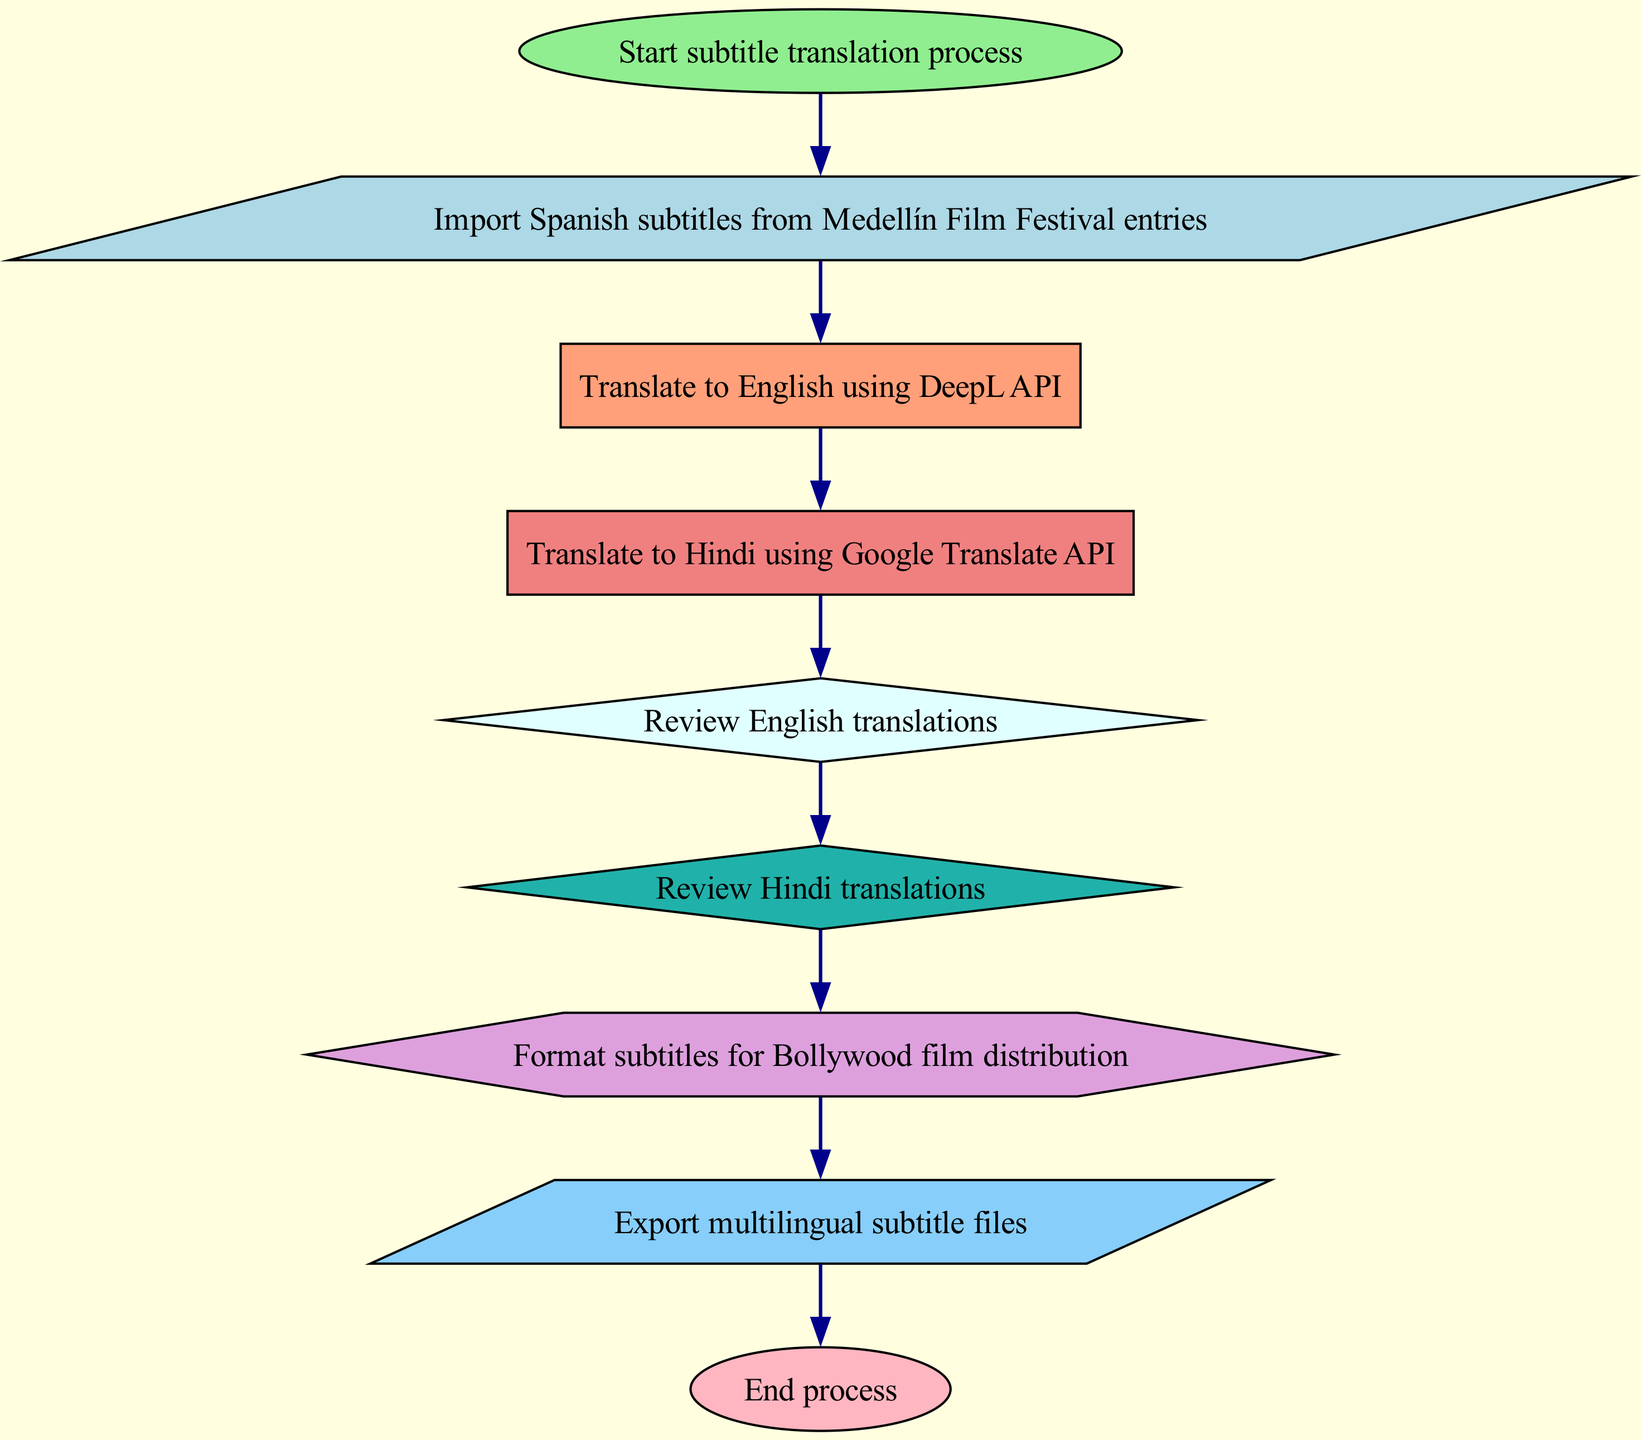What is the first step in the process? The first step is indicated by the starting node labeled "Start subtitle translation process," which signifies the beginning of the flowchart.
Answer: Start subtitle translation process How many translation steps are included in the diagram? The diagram includes two translation steps: "Translate to English using DeepL API" and "Translate to Hindi using Google Translate API." These are the only translation nodes present.
Answer: 2 What are the final actions before ending the process? Before ending the process, the final actions include "Export multilingual subtitle files," which is the last node before reaching the end node labled "End process."
Answer: Export multilingual subtitle files Which node is associated with reviewing English translations? The node labeled "Review English translations" is specifically associated with reviewing the translations that were done from Spanish to English.
Answer: Review English translations What shape is used for the nodes that involve translation? The nodes for translation are rectangles, as indicated in the diagram's node style configuration specifically for "Translate to English" and "Translate to Hindi."
Answer: Rectangle What is the last task before the subtitles are exported? The last task before exporting the subtitles is "Format subtitles for Bollywood film distribution," which must be completed before the export action.
Answer: Format subtitles for Bollywood film distribution Which API is used for translating to Hindi? The API used for translating to Hindi is Google Translate API, as specified in the node labeled "Translate to Hindi using Google Translate API."
Answer: Google Translate API How many review nodes are present in the diagram? There are two review nodes present in the diagram: "Review English translations" and "Review Hindi translations," indicating reviews for both language translations.
Answer: 2 